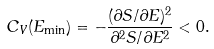Convert formula to latex. <formula><loc_0><loc_0><loc_500><loc_500>C _ { V } ( E _ { \min } ) = - \frac { ( \partial S / \partial E ) ^ { 2 } } { \partial ^ { 2 } S / \partial E ^ { 2 } } < 0 .</formula> 